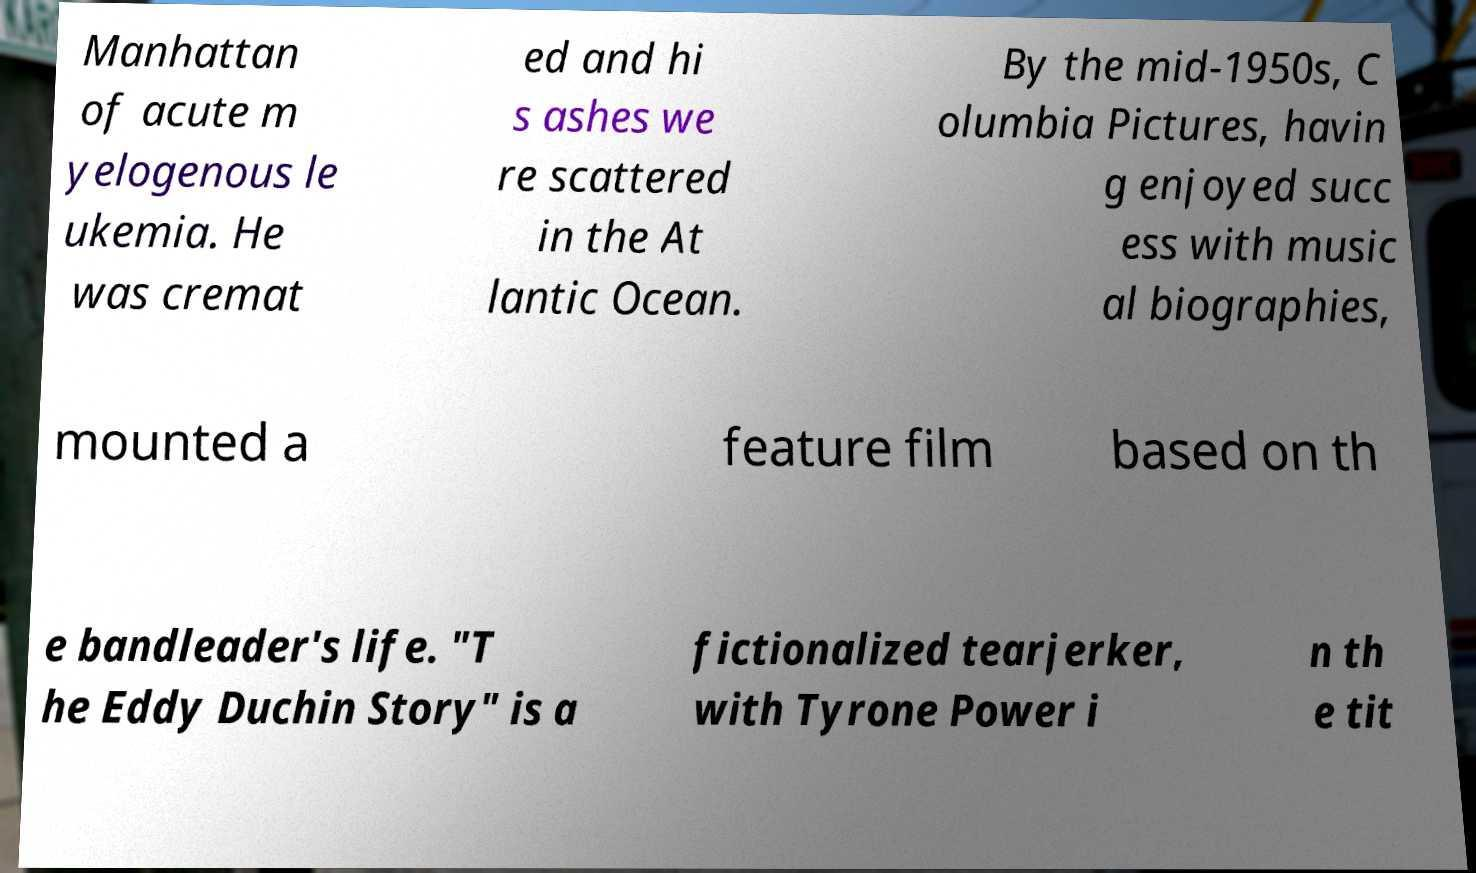Please identify and transcribe the text found in this image. Manhattan of acute m yelogenous le ukemia. He was cremat ed and hi s ashes we re scattered in the At lantic Ocean. By the mid-1950s, C olumbia Pictures, havin g enjoyed succ ess with music al biographies, mounted a feature film based on th e bandleader's life. "T he Eddy Duchin Story" is a fictionalized tearjerker, with Tyrone Power i n th e tit 